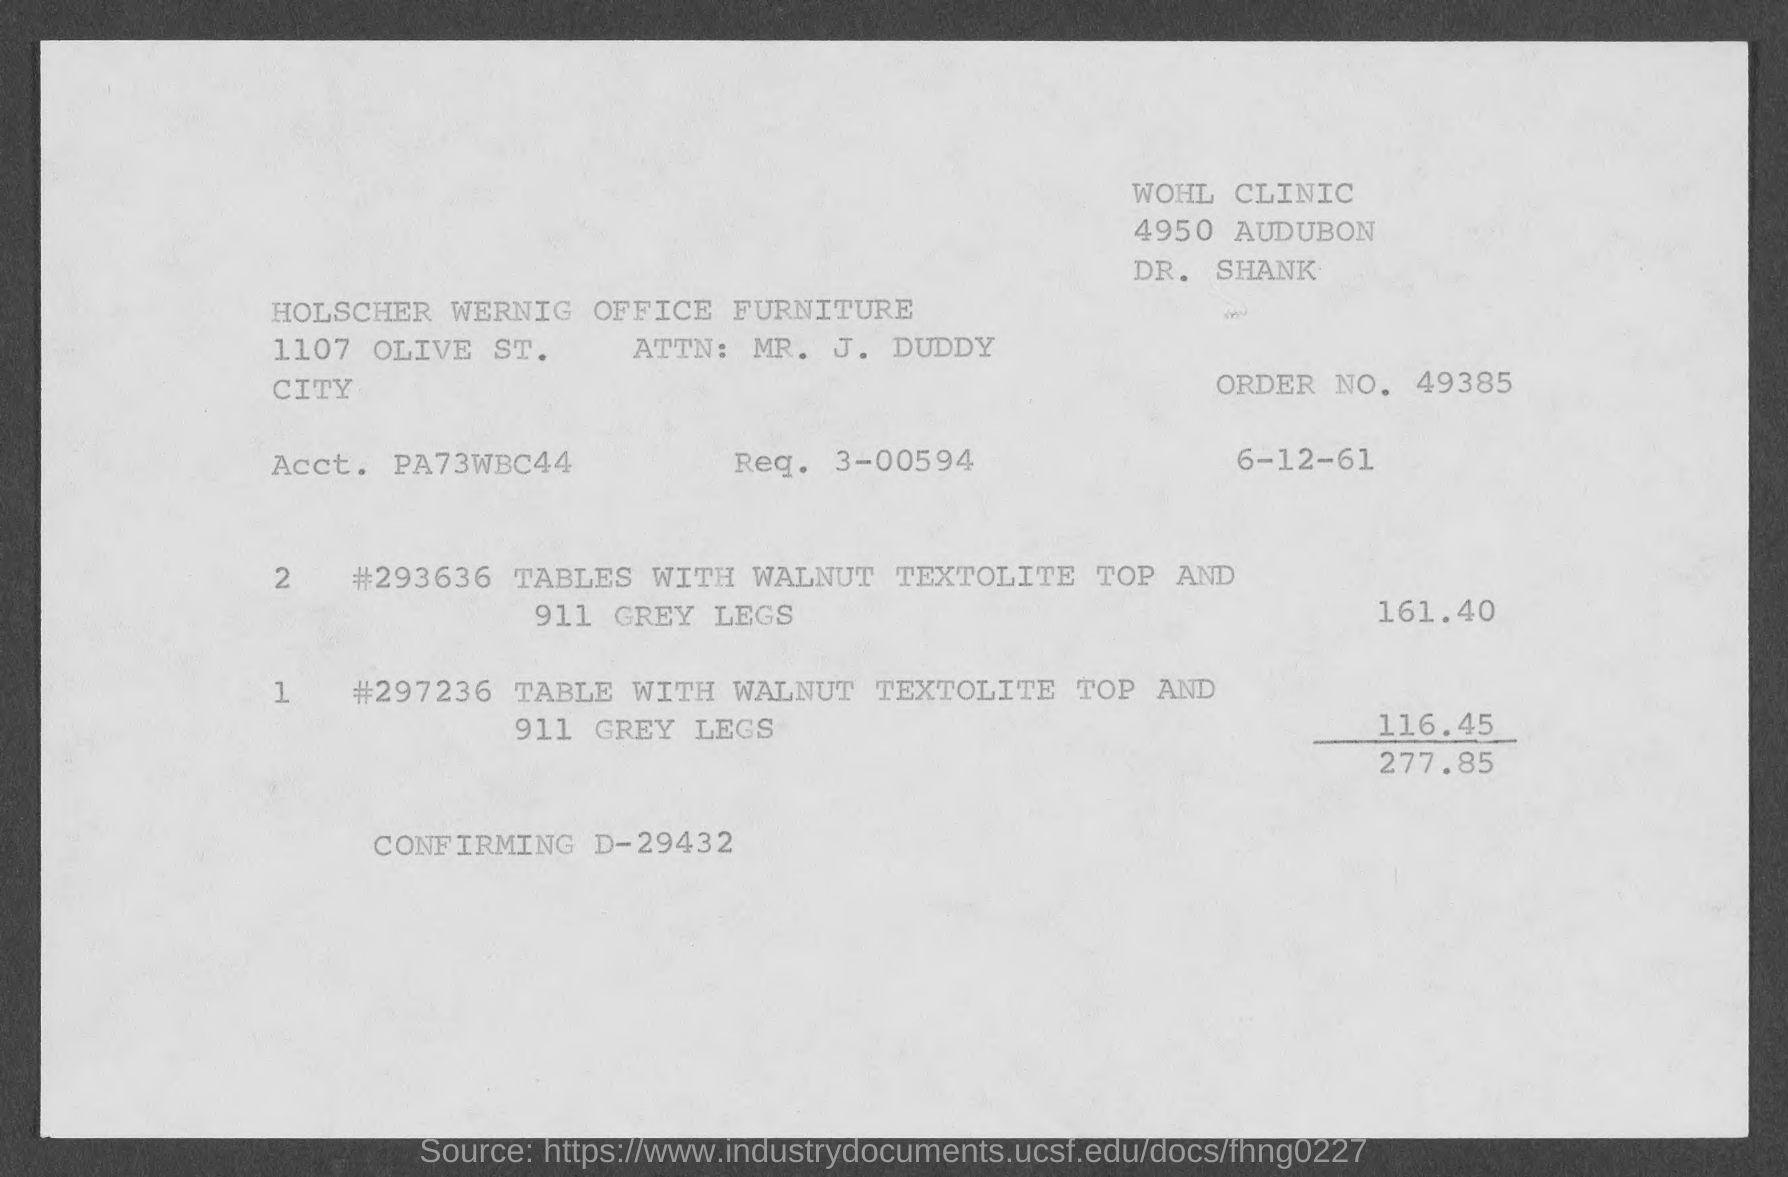What is the Order No. given in the invoice?
Provide a succinct answer. 49385. What is the Req. No. given in the invoice?
Make the answer very short. 3-00594. What is the total invoice amount given in the document?
Provide a succinct answer. 277.85. 